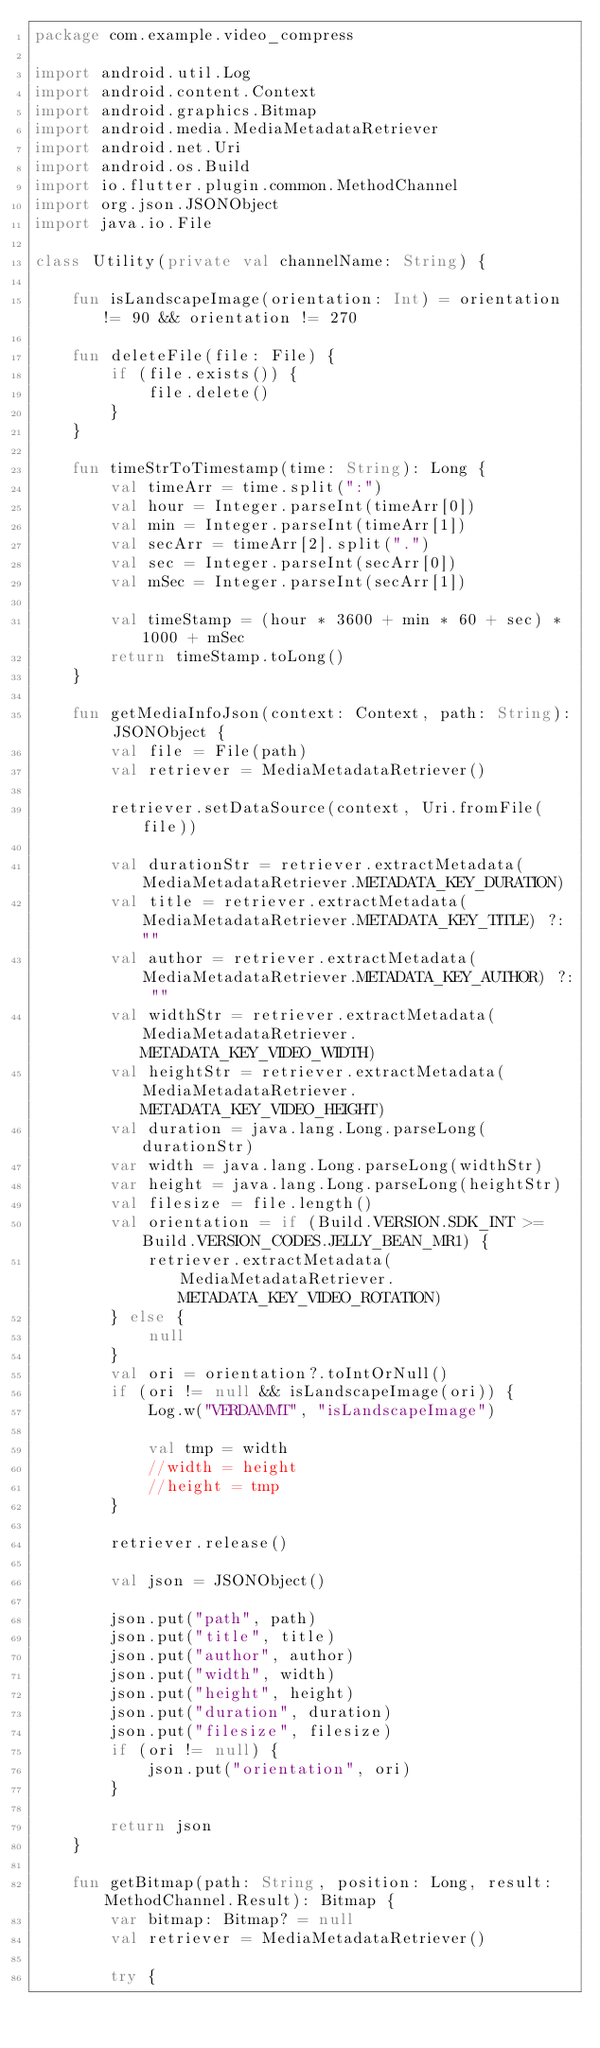Convert code to text. <code><loc_0><loc_0><loc_500><loc_500><_Kotlin_>package com.example.video_compress

import android.util.Log
import android.content.Context
import android.graphics.Bitmap
import android.media.MediaMetadataRetriever
import android.net.Uri
import android.os.Build
import io.flutter.plugin.common.MethodChannel
import org.json.JSONObject
import java.io.File

class Utility(private val channelName: String) {

    fun isLandscapeImage(orientation: Int) = orientation != 90 && orientation != 270

    fun deleteFile(file: File) {
        if (file.exists()) {
            file.delete()
        }
    }

    fun timeStrToTimestamp(time: String): Long {
        val timeArr = time.split(":")
        val hour = Integer.parseInt(timeArr[0])
        val min = Integer.parseInt(timeArr[1])
        val secArr = timeArr[2].split(".")
        val sec = Integer.parseInt(secArr[0])
        val mSec = Integer.parseInt(secArr[1])

        val timeStamp = (hour * 3600 + min * 60 + sec) * 1000 + mSec
        return timeStamp.toLong()
    }

    fun getMediaInfoJson(context: Context, path: String): JSONObject {
        val file = File(path)
        val retriever = MediaMetadataRetriever()

        retriever.setDataSource(context, Uri.fromFile(file))

        val durationStr = retriever.extractMetadata(MediaMetadataRetriever.METADATA_KEY_DURATION)
        val title = retriever.extractMetadata(MediaMetadataRetriever.METADATA_KEY_TITLE) ?: ""
        val author = retriever.extractMetadata(MediaMetadataRetriever.METADATA_KEY_AUTHOR) ?: ""
        val widthStr = retriever.extractMetadata(MediaMetadataRetriever.METADATA_KEY_VIDEO_WIDTH)
        val heightStr = retriever.extractMetadata(MediaMetadataRetriever.METADATA_KEY_VIDEO_HEIGHT)
        val duration = java.lang.Long.parseLong(durationStr)
        var width = java.lang.Long.parseLong(widthStr)
        var height = java.lang.Long.parseLong(heightStr)
        val filesize = file.length()
        val orientation = if (Build.VERSION.SDK_INT >= Build.VERSION_CODES.JELLY_BEAN_MR1) {
            retriever.extractMetadata(MediaMetadataRetriever.METADATA_KEY_VIDEO_ROTATION)
        } else {
            null
        }
        val ori = orientation?.toIntOrNull()
        if (ori != null && isLandscapeImage(ori)) {
            Log.w("VERDAMMT", "isLandscapeImage")

            val tmp = width
            //width = height
            //height = tmp
        }

        retriever.release()

        val json = JSONObject()

        json.put("path", path)
        json.put("title", title)
        json.put("author", author)
        json.put("width", width)
        json.put("height", height)
        json.put("duration", duration)
        json.put("filesize", filesize)
        if (ori != null) {
            json.put("orientation", ori)
        }

        return json
    }

    fun getBitmap(path: String, position: Long, result: MethodChannel.Result): Bitmap {
        var bitmap: Bitmap? = null
        val retriever = MediaMetadataRetriever()

        try {</code> 